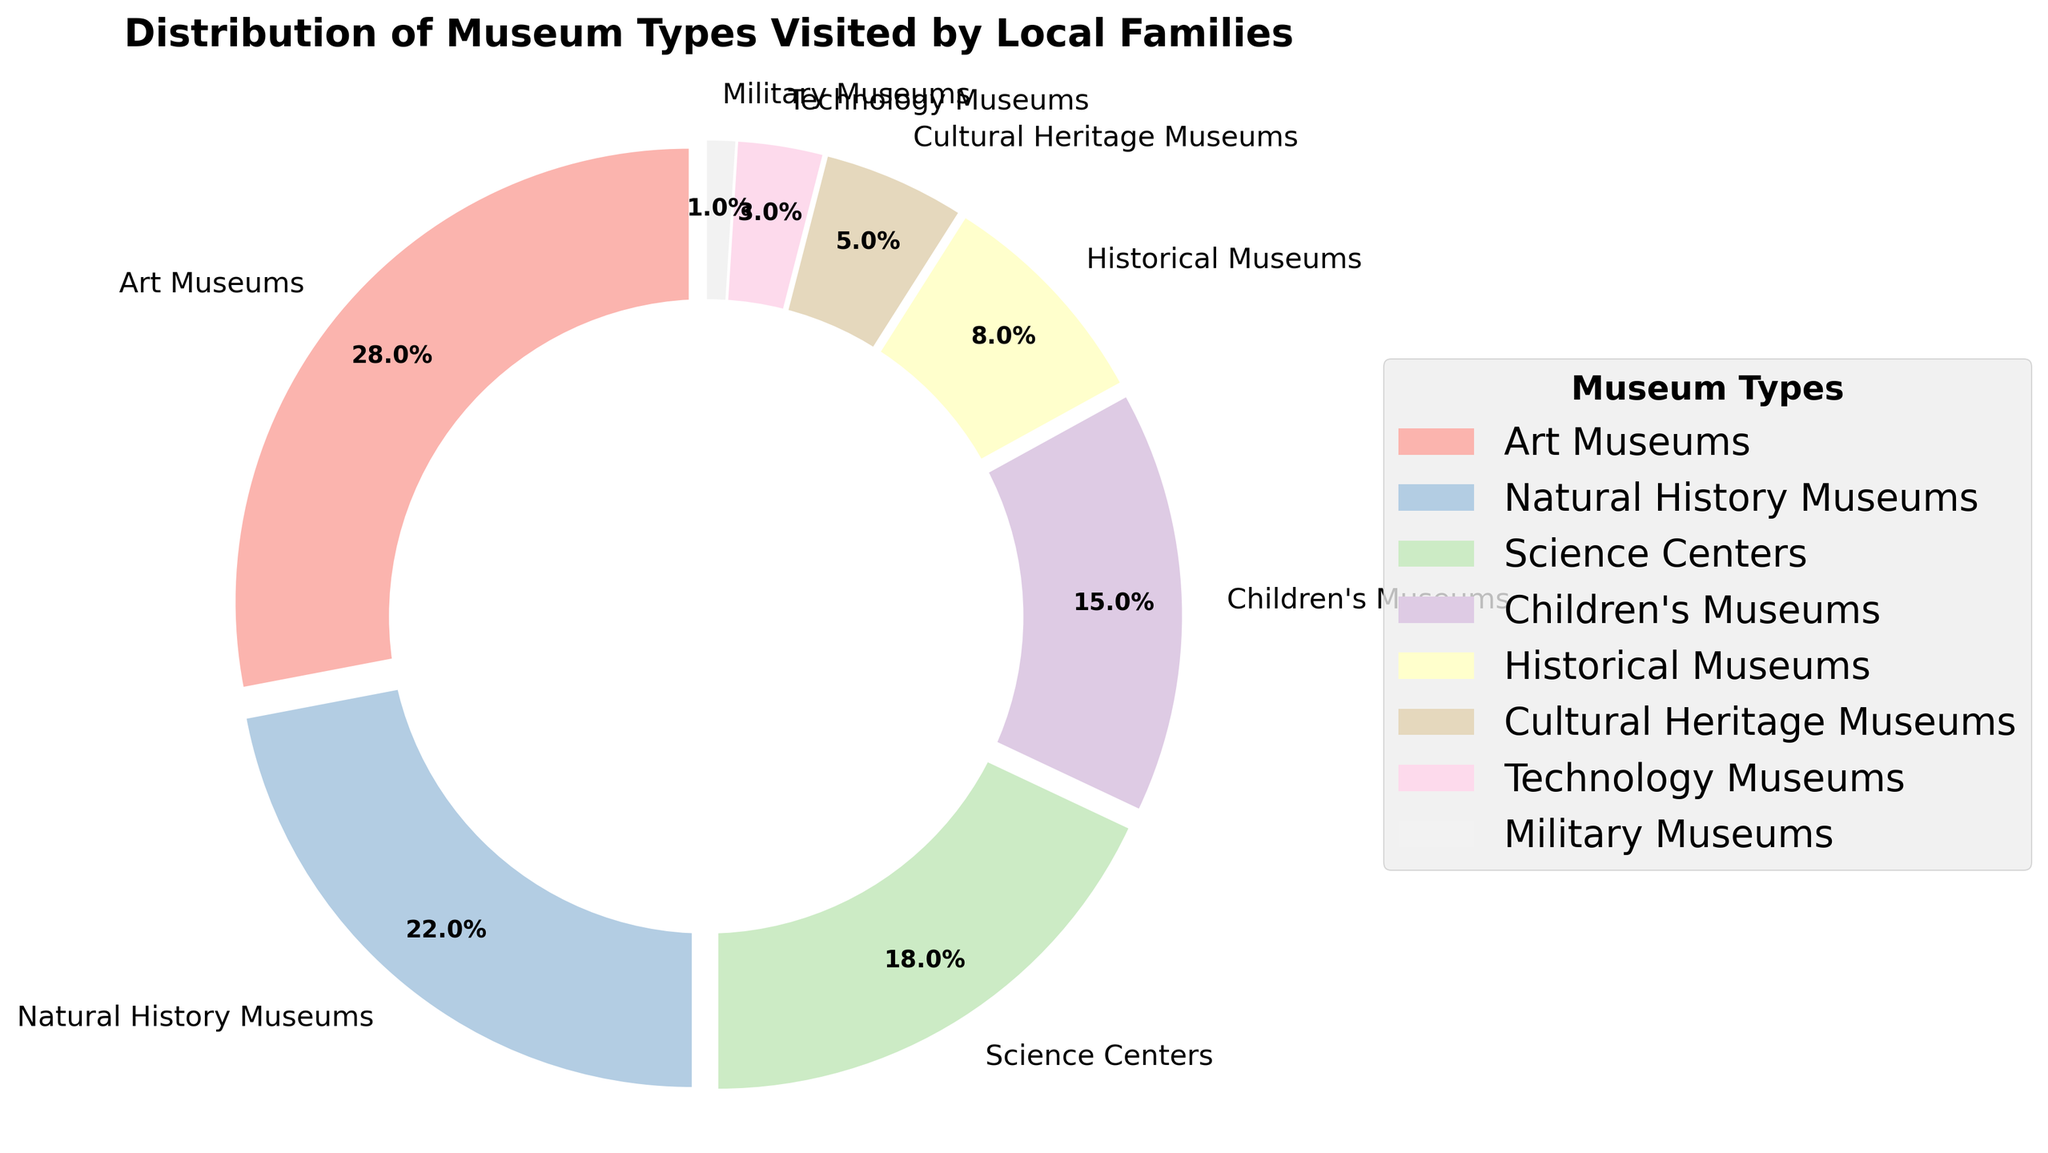What percentage of families visited Art Museums? The figure shows that Art Museums have a labeled wedge with 28%. This percentage represents the portion of families who visited Art Museums out of all museum visits.
Answer: 28% What is the combined percentage of families that visited Science Centers and Children's Museums? Science Centers have a labeled wedge showing 18%, and Children's Museums have a labeled wedge showing 15%. By adding these two percentages, 18% + 15% = 33%.
Answer: 33% Which museum type is the least visited by families? The figure shows that the wedge for Military Museums is smallest and labeled with the lowest percentage, which is 1%.
Answer: Military Museums Are there more families visiting Natural History Museums or Technology Museums? The figure shows a wedge labeled 22% for Natural History Museums and 3% for Technology Museums. Since 22% is greater than 3%, more families visit Natural History Museums.
Answer: Natural History Museums What is the total percentage of families that visited either Historical Museums or Cultural Heritage Museums? The figure shows that Historical Museums have a labeled wedge with 8%, and Cultural Heritage Museums have a labeled wedge with 5%. By adding these two percentages, 8% + 5% = 13%.
Answer: 13% Which museum types have a combined percentage exactly half of Art Museums' percentage? Art Museums have a labeled wedge showing 28%. Half of this percentage is 14%. By examining the figure, we see that Children's Museums have 15%, which is close to 14%. No two other museum types add up exactly to 14%, but Children's Museums alone are closest.
Answer: Children's Museums How much larger is the percentage of families visiting Art Museums than the percentage visiting Natural History Museums? The figure shows that the wedge for Art Museums is 28% and Natural History Museums is 22%. The difference between these two percentages is 28% - 22% = 6%.
Answer: 6% Which two museum types have a combined percentage equal to the percentage of families visiting Children's Museums? Children's Museums have a labeled wedge showing 15%. Historical Museums have 8% and Cultural Heritage Museums have 5%. By adding these two percentages, 8% + 5% = 13%, which is close but not exactly 15%. There are no exact matches, so we need to find another combination. Art Museums do not fit, and Science Centers or Natural History Museums would exceed the percentage.
Answer: No exact match What is the difference in percentage points between the most and the least visited museum types? The most visited museum type is Art Museums at 28%, and the least visited is Military Museums at 1%. The difference is 28% - 1% = 27%.
Answer: 27% What portion of the pie chart is occupied by Technology and Military Museums combined? Technology Museums have a labeled wedge showing 3% and Military Museums have 1%. By adding these percentages, 3% + 1% = 4%.
Answer: 4% 